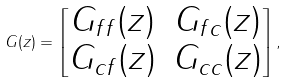<formula> <loc_0><loc_0><loc_500><loc_500>G ( z ) = \begin{bmatrix} G _ { f f } ( z ) & G _ { f c } ( z ) \\ G _ { c f } ( z ) & G _ { c c } ( z ) \end{bmatrix} ,</formula> 